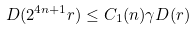Convert formula to latex. <formula><loc_0><loc_0><loc_500><loc_500>D ( 2 ^ { 4 n + 1 } r ) \leq C _ { 1 } ( n ) \gamma D ( r )</formula> 